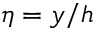<formula> <loc_0><loc_0><loc_500><loc_500>\eta = y / h</formula> 